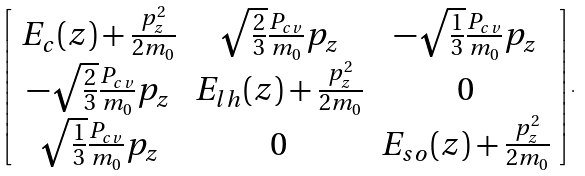Convert formula to latex. <formula><loc_0><loc_0><loc_500><loc_500>\left [ \begin{array} { c c c } E _ { c } ( z ) + \frac { p _ { z } ^ { 2 } } { 2 m _ { 0 } } & \sqrt { \frac { 2 } { 3 } } \frac { P _ { c v } } { m _ { 0 } } p _ { z } & - \sqrt { \frac { 1 } { 3 } } \frac { P _ { c v } } { m _ { 0 } } p _ { z } \\ - \sqrt { \frac { 2 } { 3 } } \frac { P _ { c v } } { m _ { 0 } } p _ { z } & E _ { l h } ( z ) + \frac { p _ { z } ^ { 2 } } { 2 m _ { 0 } } & 0 \\ \sqrt { \frac { 1 } { 3 } } \frac { P _ { c v } } { m _ { 0 } } p _ { z } & 0 & E _ { s o } ( z ) + \frac { p _ { z } ^ { 2 } } { 2 m _ { 0 } } \end{array} \right ] .</formula> 